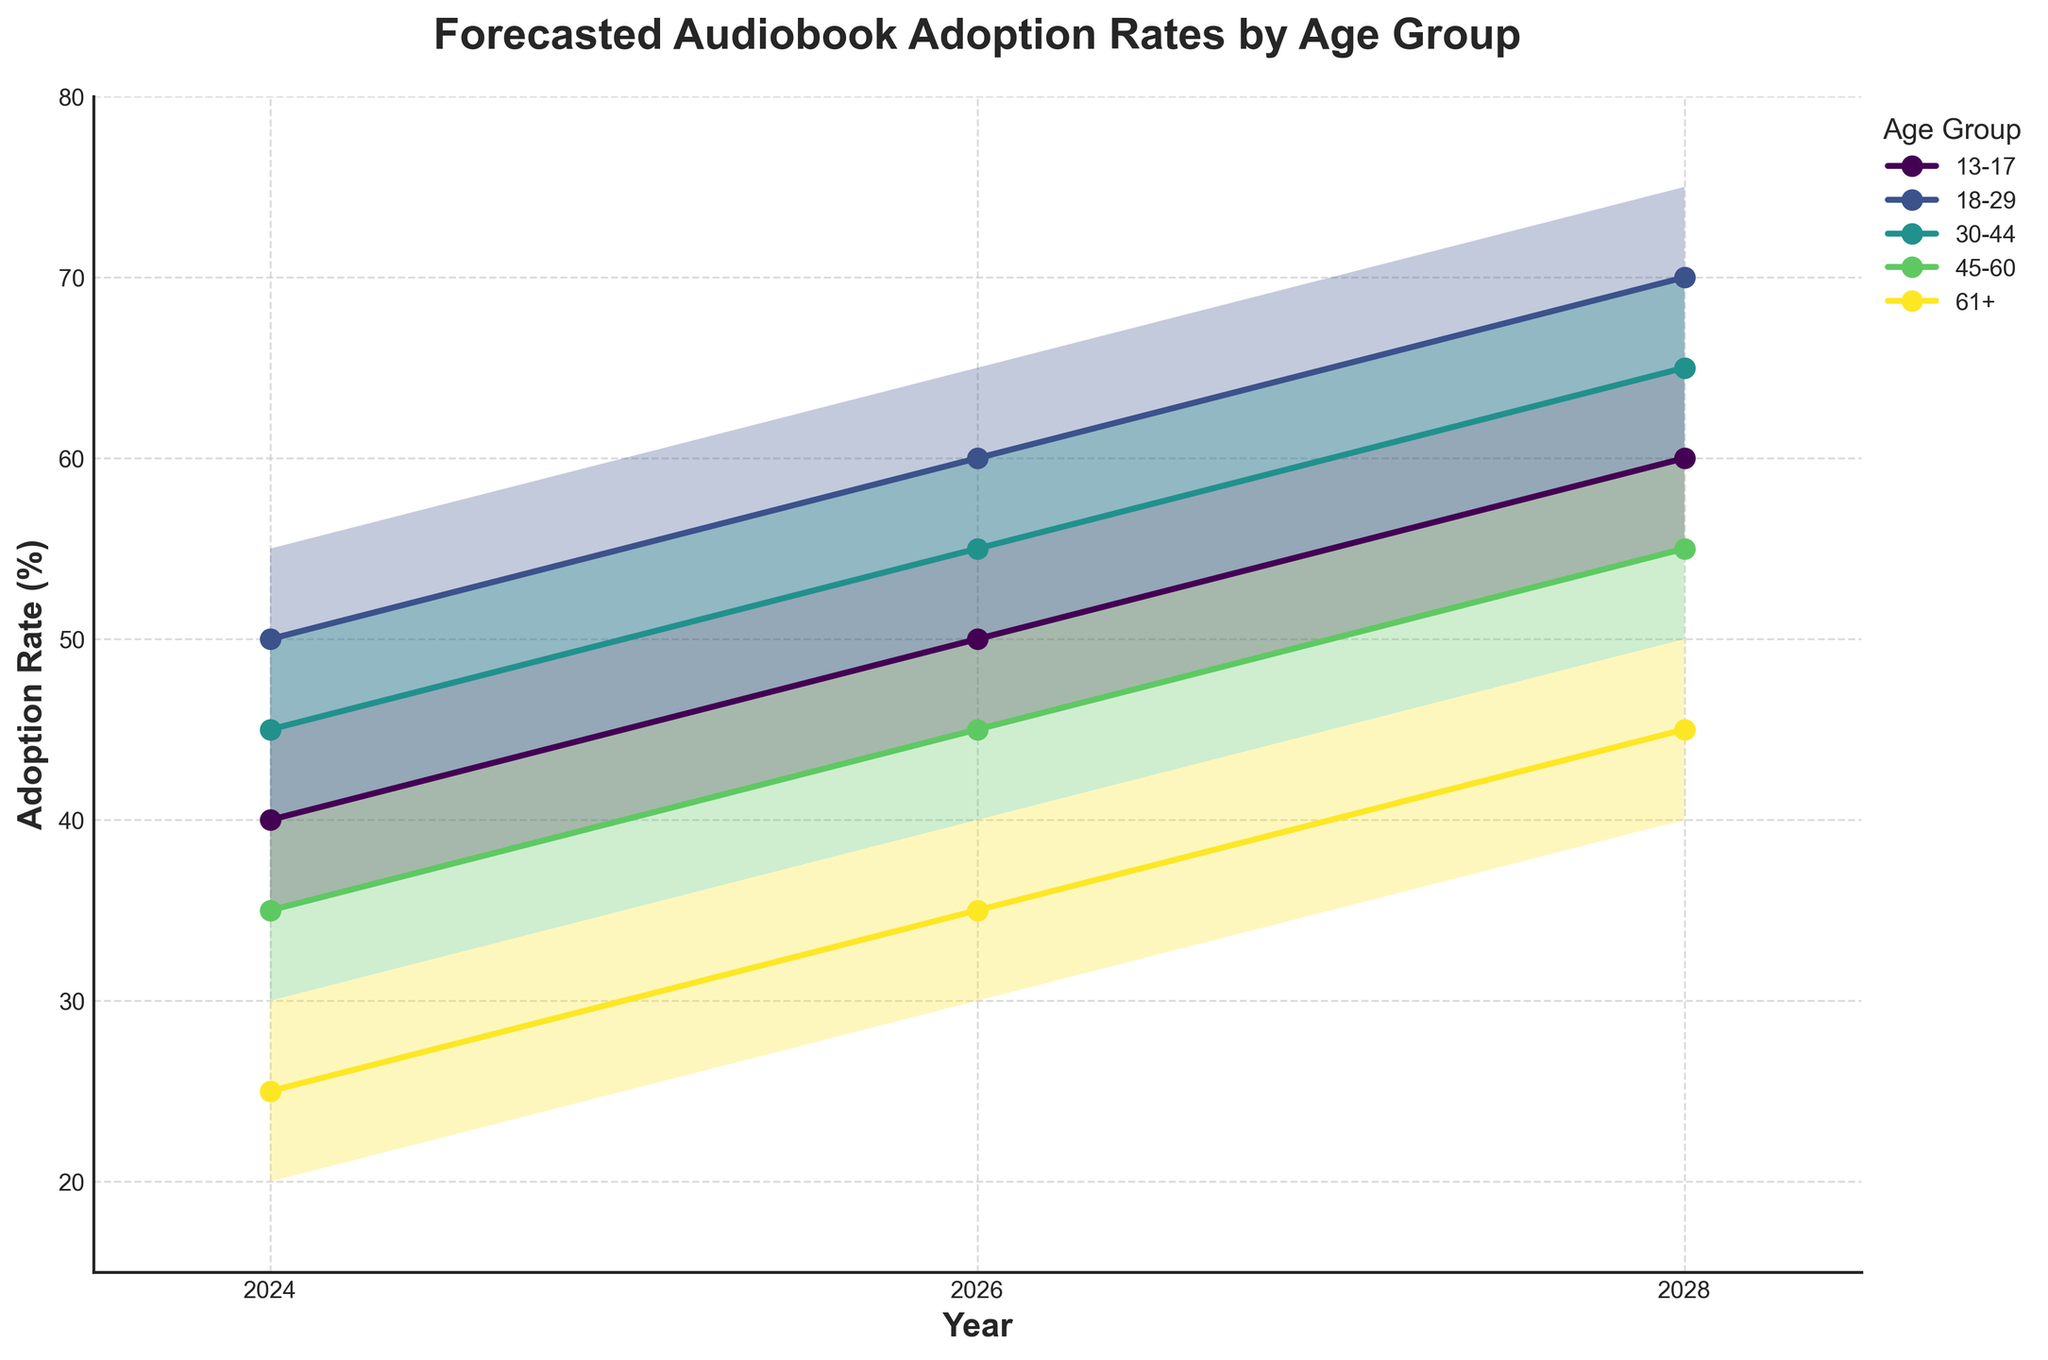What is the title of the chart? Look at the top of the chart where the title is usually placed.
Answer: Forecasted Audiobook Adoption Rates by Age Group What is the adoption rate range forecasted for the 18-29 age group in 2026? Find the year 2026 on the x-axis and check the range given for the 18-29 age group.
Answer: 55 to 65% By how much is the mid estimate adoption rate expected to increase for the 45-60 age group from 2024 to 2028? Locate the mid estimates for 2024 and 2028 for the 45-60 age group and find the difference between these values.
Answer: 20% increase Which age group has the highest mid estimate adoption rate in 2028? Check the mid estimates for all age groups in 2028 and identify the highest one.
Answer: 18-29 Compare the low estimate adoption rates for the 13-17 and 61+ age groups in 2028. Which one is higher? Refer to the low estimates for 2028 of the 13-17 and 61+ age groups and determine which value is greater.
Answer: 13-17 What is the overall trend for the adoption rates across all age groups from 2024 to 2028? Observe the changes in the mid estimate lines for all age groups from 2024 to 2028.
Answer: Increasing How much is the adoption rate for the 30-44 age group expected to increase from its low estimate in 2024 to its high estimate in 2026? Find the difference between the high estimate in 2026 and the low estimate in 2024 for the 30-44 age group.
Answer: 20% What is the adoption rate gap between the 13-17 and 45-60 age groups for the mid estimates in 2024? Subtract the mid estimate of the 45-60 age group from the mid estimate of the 13-17 age group in 2024.
Answer: 5% For which age group does the adoption rate show the smallest increase in the mid estimate from 2024 to 2028? Calculate the difference in mid estimates from 2024 to 2028 for each age group and identify the smallest increase.
Answer: 61+ Which age group has the widest forecast range (difference between high and low estimates) in 2028? Calculate the difference between the high and low estimates for each age group in 2028 and identify the widest range.
Answer: 18-29 